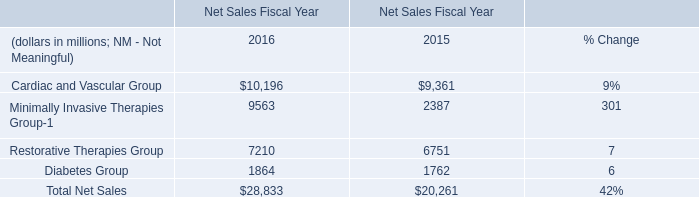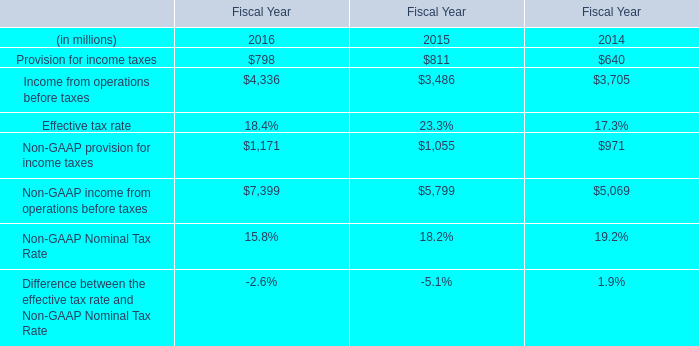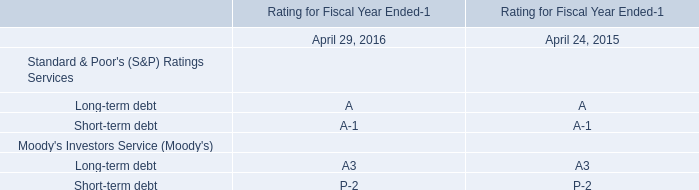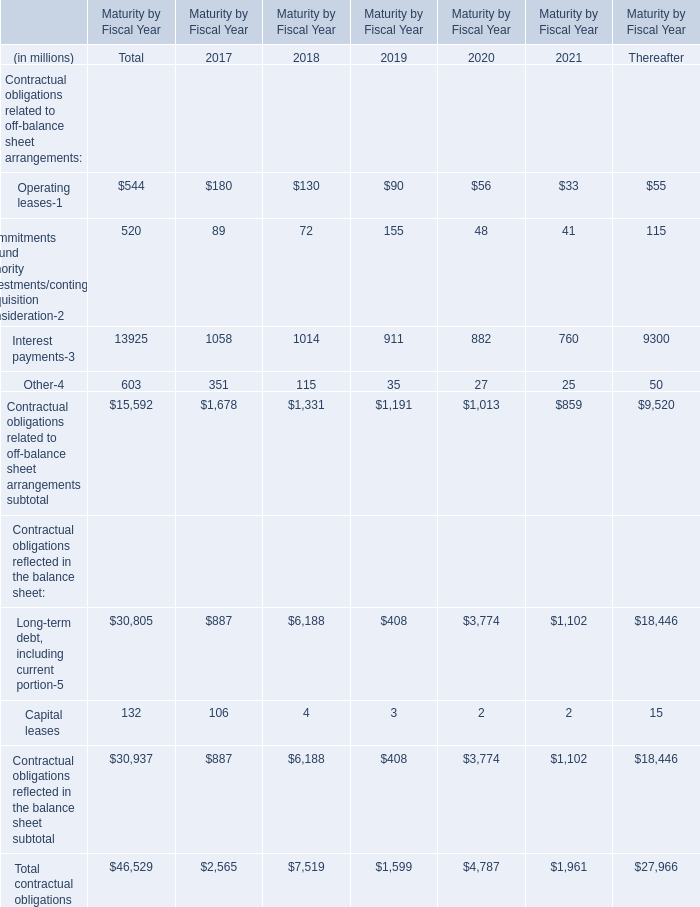What is the sum of Total contractual obligations in 2017 and Diabetes Group in 2015? (in million) 
Computations: (2565 + 1762)
Answer: 4327.0. 